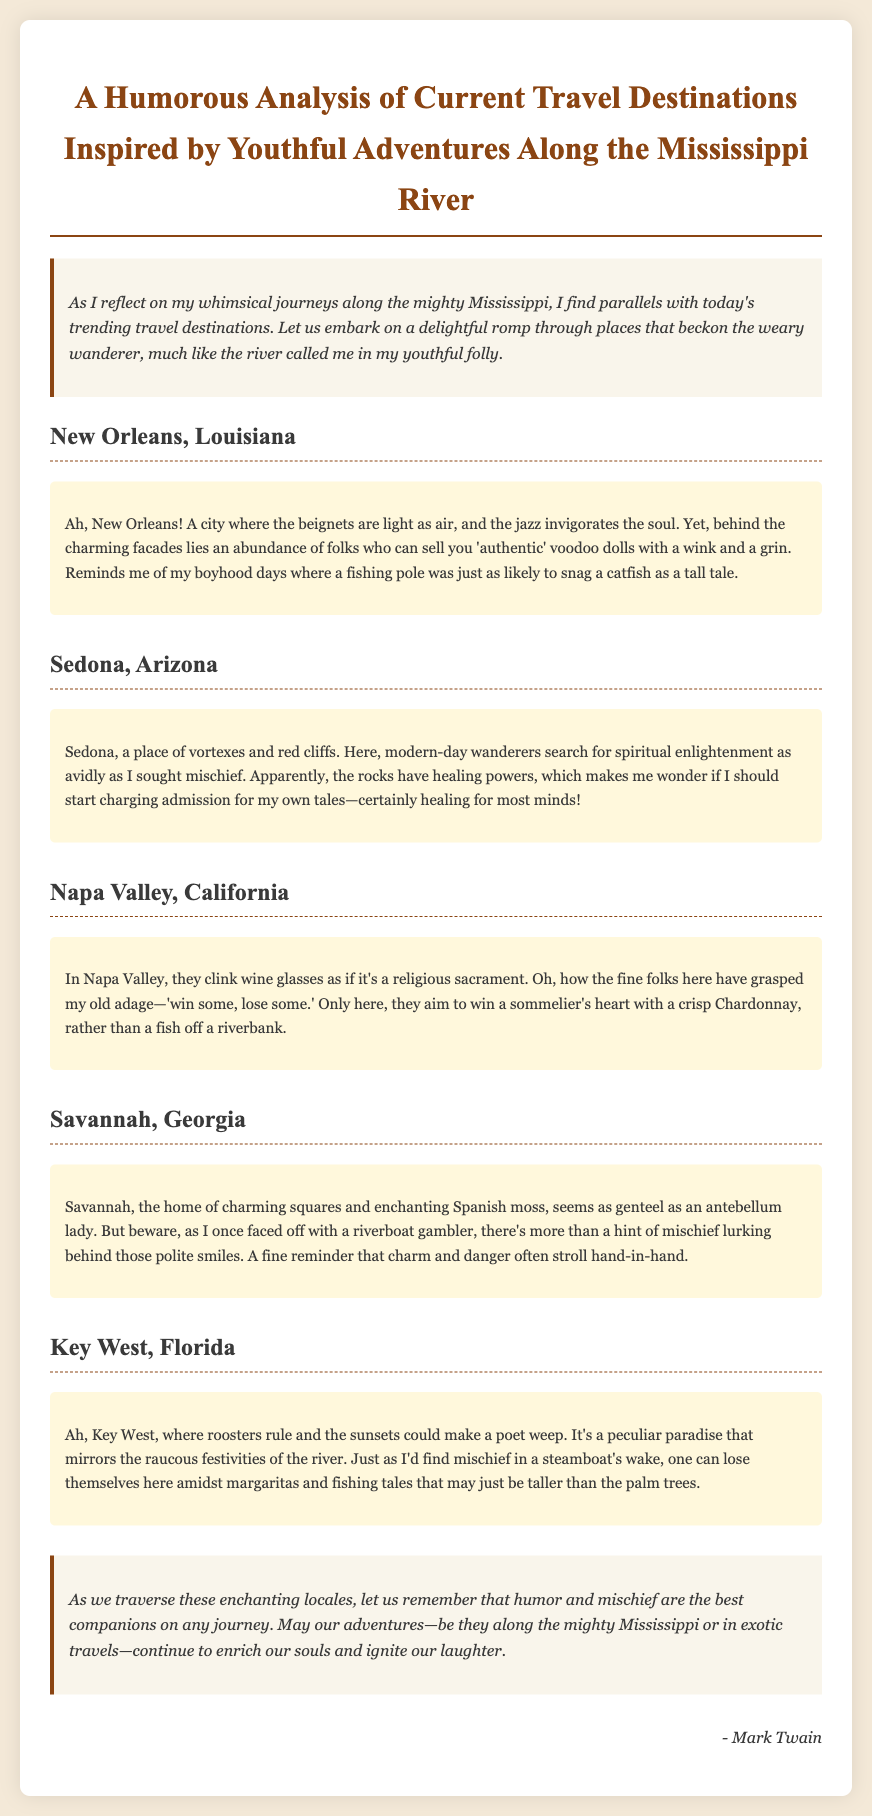What is the title of the memo? The title of the memo is stated clearly at the top of the document.
Answer: A Humorous Analysis of Current Travel Destinations Inspired by Youthful Adventures Along the Mississippi River How many travel destinations are analyzed in the memo? The memo discusses five different travel destinations.
Answer: Five Which city is known for its beignets? This information is provided in the section dedicated to the specific city and its corresponding insights.
Answer: New Orleans What is the description of Sedona? The memo provides specific insights about Sedona, mentioning its unique features.
Answer: A place of vortexes and red cliffs What item does Napa Valley winemakers focus on? The memo humorously reflects on Napa Valley's signature products and activities.
Answer: Wine glasses How does the author describe Key West's atmosphere? The description of Key West illustrates the ambiance and charm of the location.
Answer: Peculiar paradise What common theme is emphasized in the conclusion? The conclusion summarizes what is valuable during journeys, as stated by the author.
Answer: Humor and mischief What does the author compare spiritual searches in Sedona to? The author relates spiritual enlightenment to their own youthful pursuits.
Answer: Mischief Who is the author of the memo? The author's name is mentioned at the end of the document, indicating authorship.
Answer: Mark Twain 